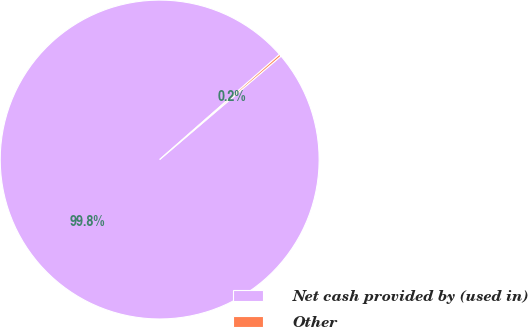Convert chart. <chart><loc_0><loc_0><loc_500><loc_500><pie_chart><fcel>Net cash provided by (used in)<fcel>Other<nl><fcel>99.78%<fcel>0.22%<nl></chart> 